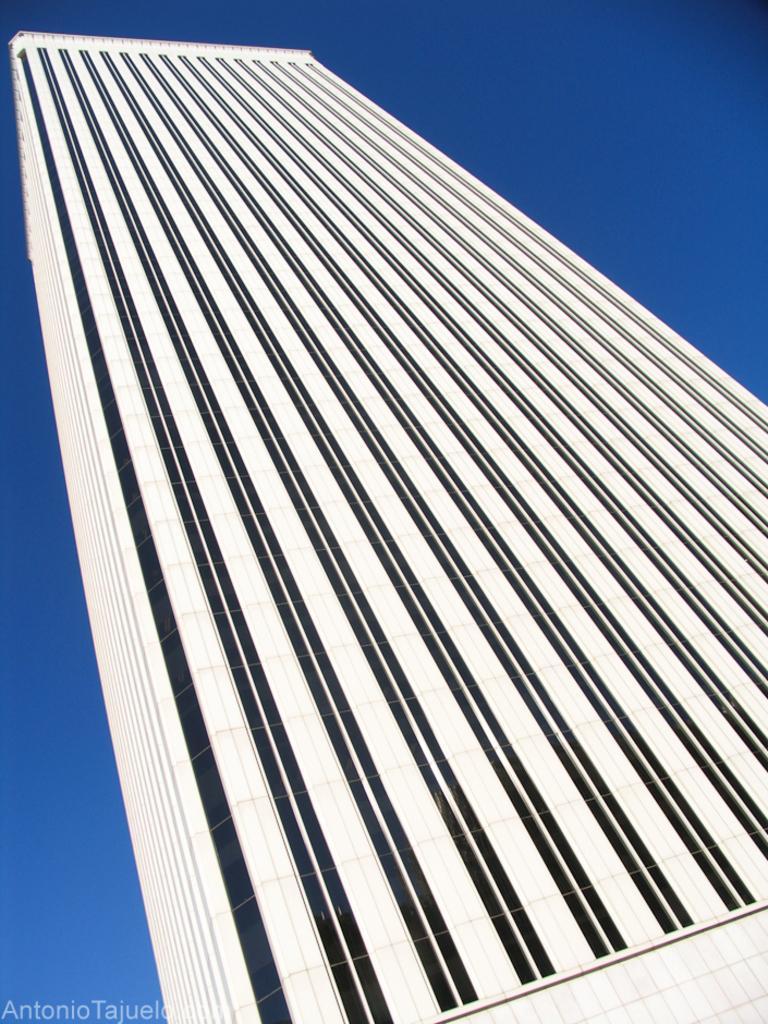In one or two sentences, can you explain what this image depicts? In this image, we can see a building with walls and glasses. Background there is a sky. At the bottom of the image, we can see a watermark. 